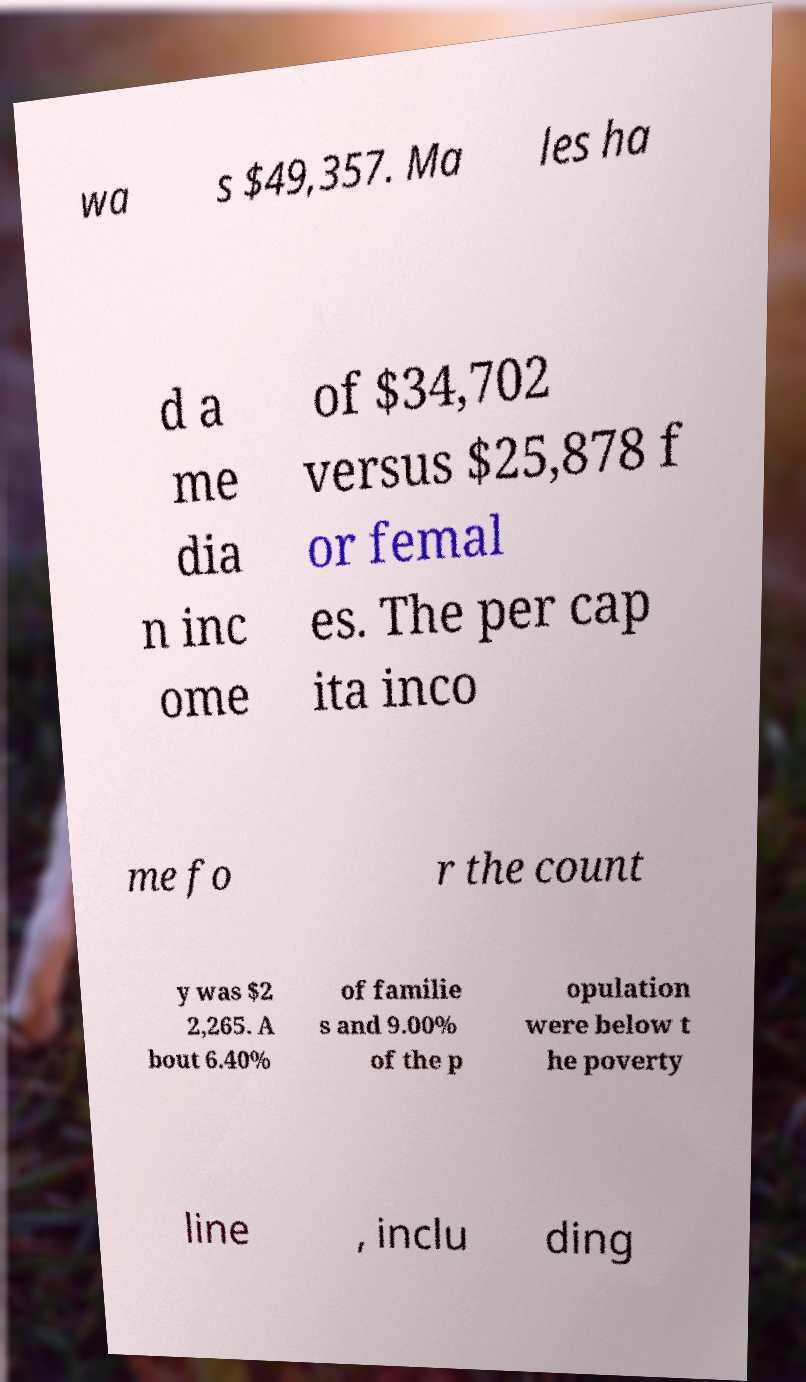Could you extract and type out the text from this image? wa s $49,357. Ma les ha d a me dia n inc ome of $34,702 versus $25,878 f or femal es. The per cap ita inco me fo r the count y was $2 2,265. A bout 6.40% of familie s and 9.00% of the p opulation were below t he poverty line , inclu ding 